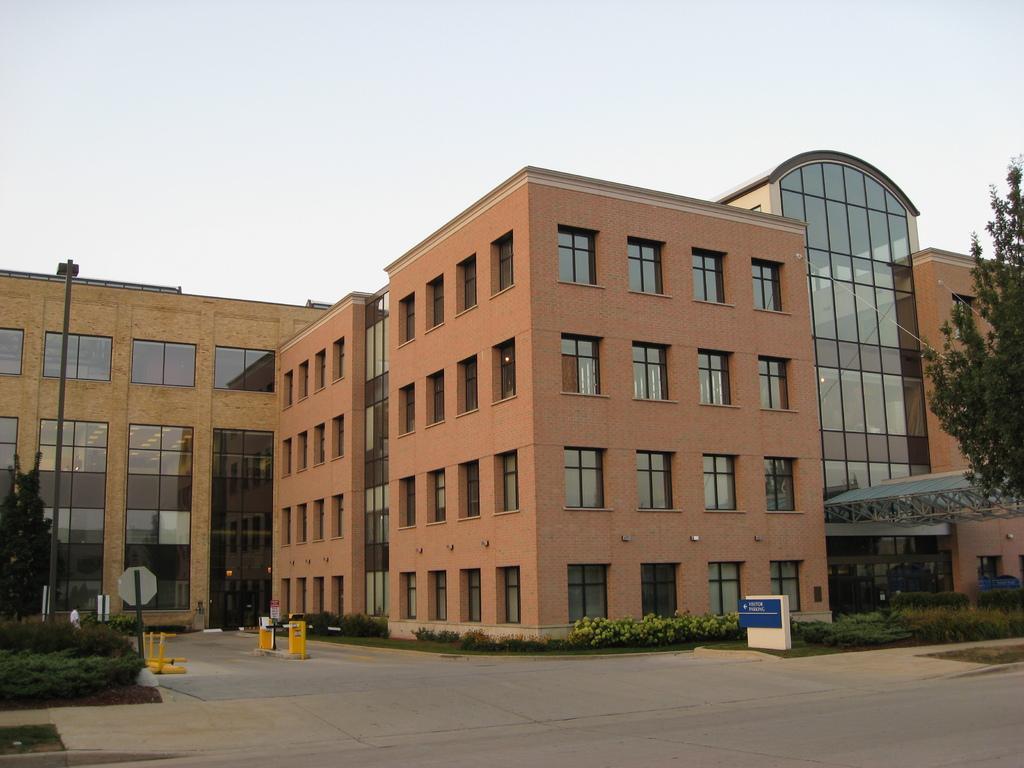How would you summarize this image in a sentence or two? In the image there is a building in the front with many windows and glass panels with plants and garden in front of it and above its sky. 